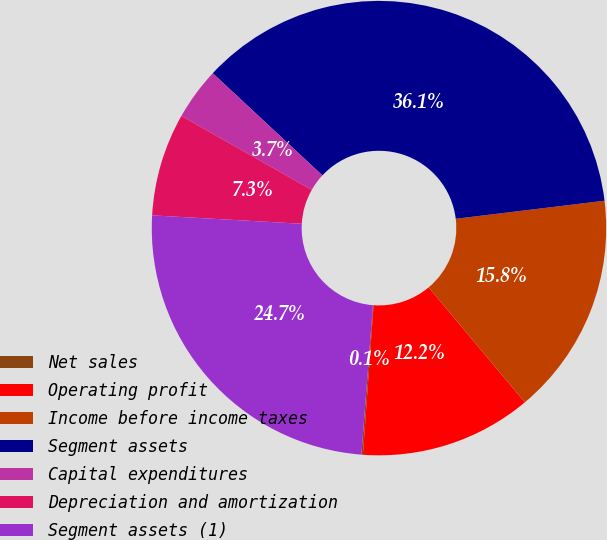<chart> <loc_0><loc_0><loc_500><loc_500><pie_chart><fcel>Net sales<fcel>Operating profit<fcel>Income before income taxes<fcel>Segment assets<fcel>Capital expenditures<fcel>Depreciation and amortization<fcel>Segment assets (1)<nl><fcel>0.11%<fcel>12.22%<fcel>15.83%<fcel>36.14%<fcel>3.72%<fcel>7.32%<fcel>24.66%<nl></chart> 